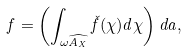<formula> <loc_0><loc_0><loc_500><loc_500>f = \left ( \int _ { \omega \widehat { A _ { X } } } \check { f } ( \chi ) d \chi \right ) d a ,</formula> 